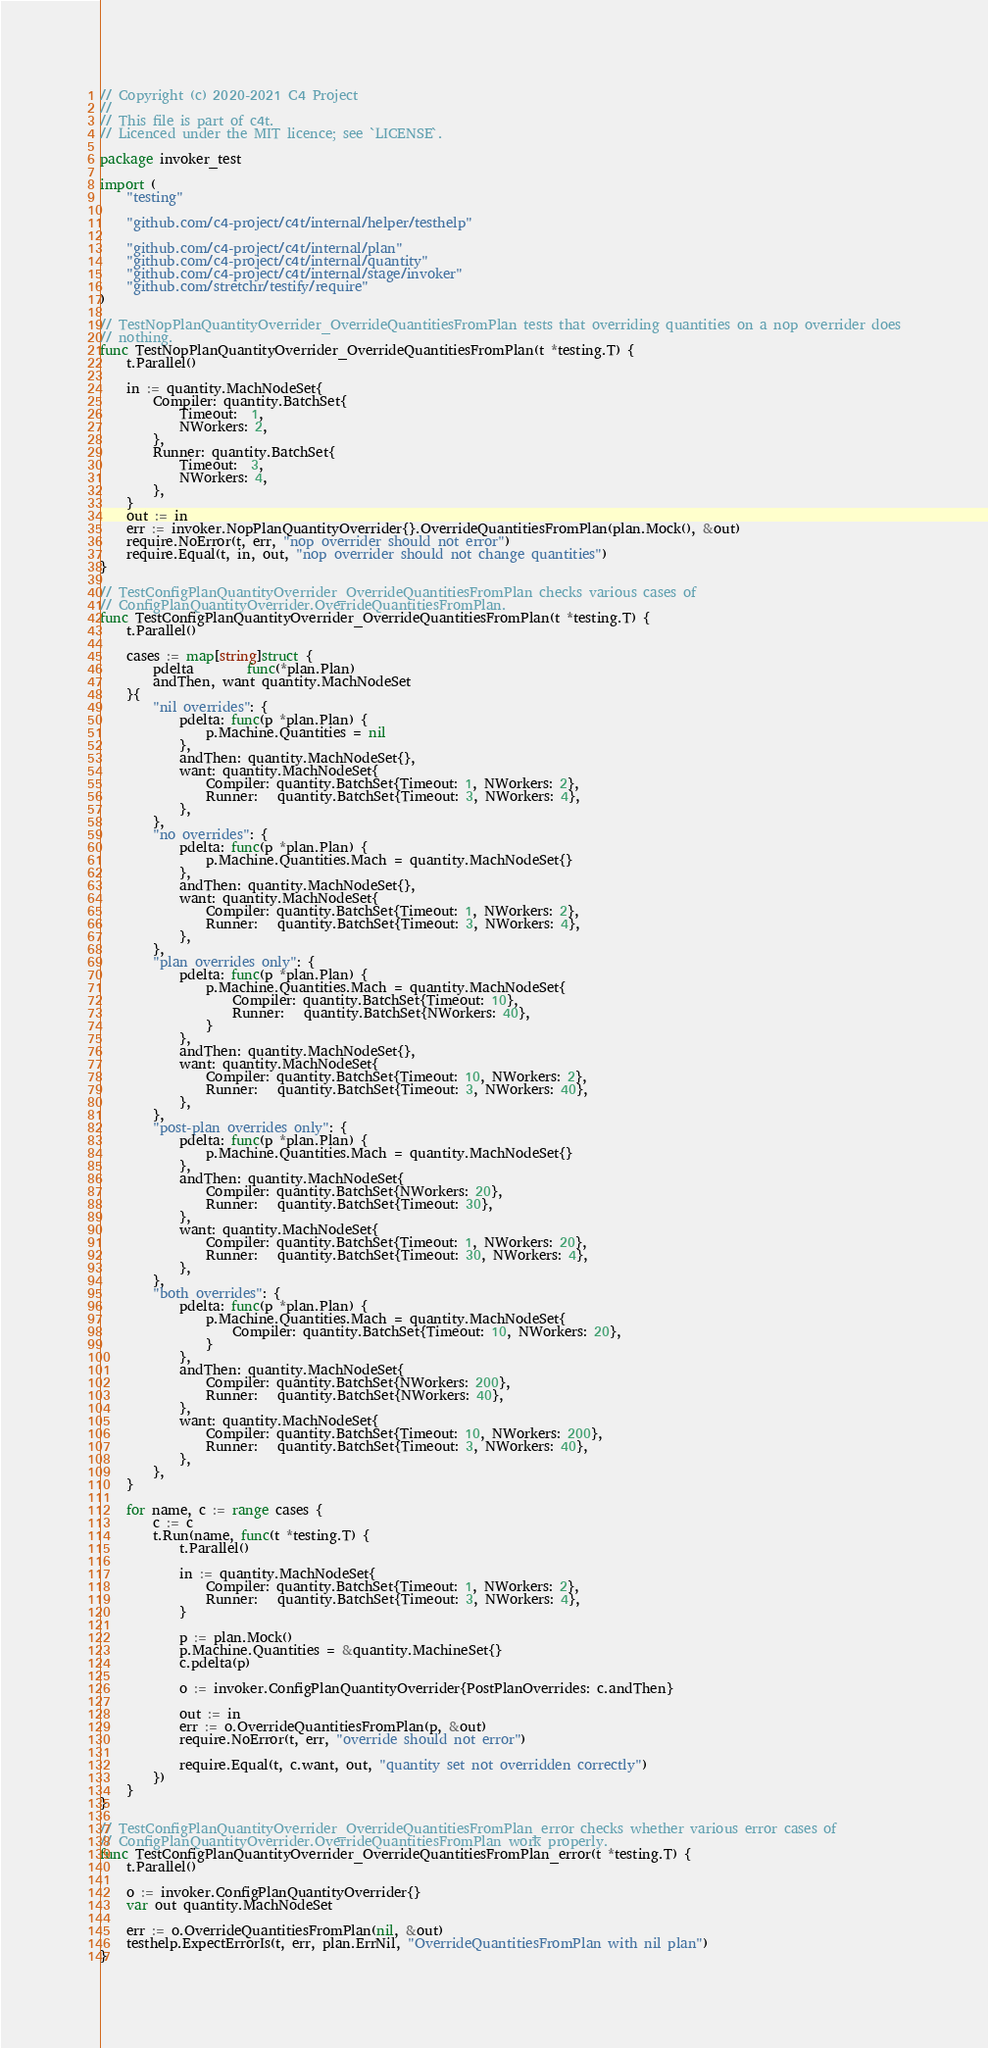Convert code to text. <code><loc_0><loc_0><loc_500><loc_500><_Go_>// Copyright (c) 2020-2021 C4 Project
//
// This file is part of c4t.
// Licenced under the MIT licence; see `LICENSE`.

package invoker_test

import (
	"testing"

	"github.com/c4-project/c4t/internal/helper/testhelp"

	"github.com/c4-project/c4t/internal/plan"
	"github.com/c4-project/c4t/internal/quantity"
	"github.com/c4-project/c4t/internal/stage/invoker"
	"github.com/stretchr/testify/require"
)

// TestNopPlanQuantityOverrider_OverrideQuantitiesFromPlan tests that overriding quantities on a nop overrider does
// nothing.
func TestNopPlanQuantityOverrider_OverrideQuantitiesFromPlan(t *testing.T) {
	t.Parallel()

	in := quantity.MachNodeSet{
		Compiler: quantity.BatchSet{
			Timeout:  1,
			NWorkers: 2,
		},
		Runner: quantity.BatchSet{
			Timeout:  3,
			NWorkers: 4,
		},
	}
	out := in
	err := invoker.NopPlanQuantityOverrider{}.OverrideQuantitiesFromPlan(plan.Mock(), &out)
	require.NoError(t, err, "nop overrider should not error")
	require.Equal(t, in, out, "nop overrider should not change quantities")
}

// TestConfigPlanQuantityOverrider_OverrideQuantitiesFromPlan checks various cases of
// ConfigPlanQuantityOverrider.OverrideQuantitiesFromPlan.
func TestConfigPlanQuantityOverrider_OverrideQuantitiesFromPlan(t *testing.T) {
	t.Parallel()

	cases := map[string]struct {
		pdelta        func(*plan.Plan)
		andThen, want quantity.MachNodeSet
	}{
		"nil overrides": {
			pdelta: func(p *plan.Plan) {
				p.Machine.Quantities = nil
			},
			andThen: quantity.MachNodeSet{},
			want: quantity.MachNodeSet{
				Compiler: quantity.BatchSet{Timeout: 1, NWorkers: 2},
				Runner:   quantity.BatchSet{Timeout: 3, NWorkers: 4},
			},
		},
		"no overrides": {
			pdelta: func(p *plan.Plan) {
				p.Machine.Quantities.Mach = quantity.MachNodeSet{}
			},
			andThen: quantity.MachNodeSet{},
			want: quantity.MachNodeSet{
				Compiler: quantity.BatchSet{Timeout: 1, NWorkers: 2},
				Runner:   quantity.BatchSet{Timeout: 3, NWorkers: 4},
			},
		},
		"plan overrides only": {
			pdelta: func(p *plan.Plan) {
				p.Machine.Quantities.Mach = quantity.MachNodeSet{
					Compiler: quantity.BatchSet{Timeout: 10},
					Runner:   quantity.BatchSet{NWorkers: 40},
				}
			},
			andThen: quantity.MachNodeSet{},
			want: quantity.MachNodeSet{
				Compiler: quantity.BatchSet{Timeout: 10, NWorkers: 2},
				Runner:   quantity.BatchSet{Timeout: 3, NWorkers: 40},
			},
		},
		"post-plan overrides only": {
			pdelta: func(p *plan.Plan) {
				p.Machine.Quantities.Mach = quantity.MachNodeSet{}
			},
			andThen: quantity.MachNodeSet{
				Compiler: quantity.BatchSet{NWorkers: 20},
				Runner:   quantity.BatchSet{Timeout: 30},
			},
			want: quantity.MachNodeSet{
				Compiler: quantity.BatchSet{Timeout: 1, NWorkers: 20},
				Runner:   quantity.BatchSet{Timeout: 30, NWorkers: 4},
			},
		},
		"both overrides": {
			pdelta: func(p *plan.Plan) {
				p.Machine.Quantities.Mach = quantity.MachNodeSet{
					Compiler: quantity.BatchSet{Timeout: 10, NWorkers: 20},
				}
			},
			andThen: quantity.MachNodeSet{
				Compiler: quantity.BatchSet{NWorkers: 200},
				Runner:   quantity.BatchSet{NWorkers: 40},
			},
			want: quantity.MachNodeSet{
				Compiler: quantity.BatchSet{Timeout: 10, NWorkers: 200},
				Runner:   quantity.BatchSet{Timeout: 3, NWorkers: 40},
			},
		},
	}

	for name, c := range cases {
		c := c
		t.Run(name, func(t *testing.T) {
			t.Parallel()

			in := quantity.MachNodeSet{
				Compiler: quantity.BatchSet{Timeout: 1, NWorkers: 2},
				Runner:   quantity.BatchSet{Timeout: 3, NWorkers: 4},
			}

			p := plan.Mock()
			p.Machine.Quantities = &quantity.MachineSet{}
			c.pdelta(p)

			o := invoker.ConfigPlanQuantityOverrider{PostPlanOverrides: c.andThen}

			out := in
			err := o.OverrideQuantitiesFromPlan(p, &out)
			require.NoError(t, err, "override should not error")

			require.Equal(t, c.want, out, "quantity set not overridden correctly")
		})
	}
}

// TestConfigPlanQuantityOverrider_OverrideQuantitiesFromPlan_error checks whether various error cases of
// ConfigPlanQuantityOverrider.OverrideQuantitiesFromPlan work properly.
func TestConfigPlanQuantityOverrider_OverrideQuantitiesFromPlan_error(t *testing.T) {
	t.Parallel()

	o := invoker.ConfigPlanQuantityOverrider{}
	var out quantity.MachNodeSet

	err := o.OverrideQuantitiesFromPlan(nil, &out)
	testhelp.ExpectErrorIs(t, err, plan.ErrNil, "OverrideQuantitiesFromPlan with nil plan")
}
</code> 